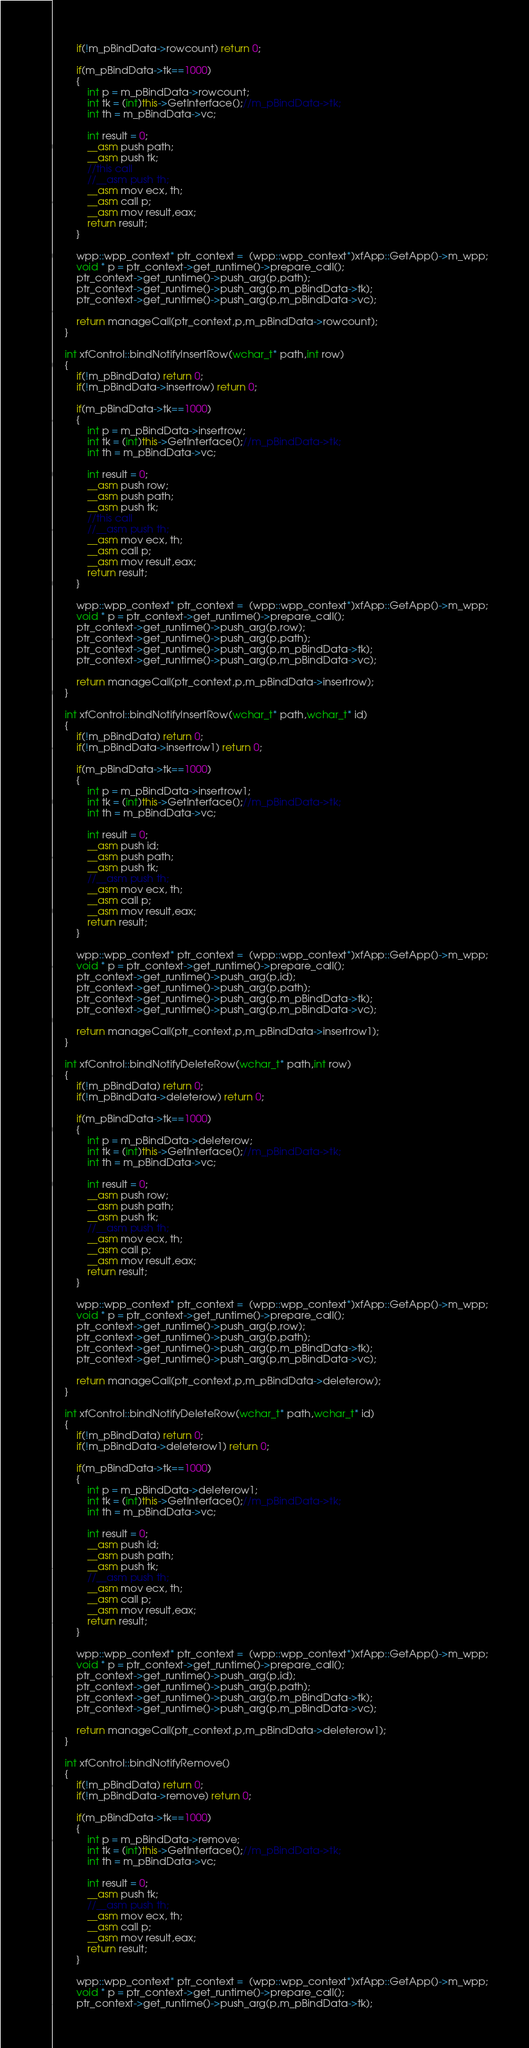Convert code to text. <code><loc_0><loc_0><loc_500><loc_500><_C++_>		if(!m_pBindData->rowcount) return 0;

		if(m_pBindData->tk==1000)
		{
			int p = m_pBindData->rowcount;
			int tk = (int)this->GetInterface();//m_pBindData->tk;
			int th = m_pBindData->vc;

			int result = 0;
			__asm push path;
			__asm push tk;
			//this call
			//__asm push th;
			__asm mov ecx, th;
			__asm call p;
			__asm mov result,eax;
			return result;
		}

		wpp::wpp_context* ptr_context =  (wpp::wpp_context*)xfApp::GetApp()->m_wpp;
		void * p = ptr_context->get_runtime()->prepare_call();
		ptr_context->get_runtime()->push_arg(p,path);
		ptr_context->get_runtime()->push_arg(p,m_pBindData->tk);
		ptr_context->get_runtime()->push_arg(p,m_pBindData->vc);
		
		return manageCall(ptr_context,p,m_pBindData->rowcount);
	}

	int xfControl::bindNotifyInsertRow(wchar_t* path,int row)
	{
		if(!m_pBindData) return 0;
		if(!m_pBindData->insertrow) return 0;

		if(m_pBindData->tk==1000)
		{
			int p = m_pBindData->insertrow;
			int tk = (int)this->GetInterface();//m_pBindData->tk;
			int th = m_pBindData->vc;

			int result = 0;
			__asm push row;
			__asm push path;
			__asm push tk;
			//this call
			//__asm push th;
			__asm mov ecx, th;
			__asm call p;
			__asm mov result,eax;
			return result;
		}

		wpp::wpp_context* ptr_context =  (wpp::wpp_context*)xfApp::GetApp()->m_wpp;
		void * p = ptr_context->get_runtime()->prepare_call();
		ptr_context->get_runtime()->push_arg(p,row);
		ptr_context->get_runtime()->push_arg(p,path);
		ptr_context->get_runtime()->push_arg(p,m_pBindData->tk);
		ptr_context->get_runtime()->push_arg(p,m_pBindData->vc);
		
		return manageCall(ptr_context,p,m_pBindData->insertrow);
	}

	int xfControl::bindNotifyInsertRow(wchar_t* path,wchar_t* id)
	{
		if(!m_pBindData) return 0;
		if(!m_pBindData->insertrow1) return 0;

		if(m_pBindData->tk==1000)
		{
			int p = m_pBindData->insertrow1;
			int tk = (int)this->GetInterface();//m_pBindData->tk;
			int th = m_pBindData->vc;

			int result = 0;
			__asm push id;
			__asm push path;
			__asm push tk;
			//__asm push th;
			__asm mov ecx, th;
			__asm call p;
			__asm mov result,eax;
			return result;
		}

		wpp::wpp_context* ptr_context =  (wpp::wpp_context*)xfApp::GetApp()->m_wpp;
		void * p = ptr_context->get_runtime()->prepare_call();
		ptr_context->get_runtime()->push_arg(p,id);
		ptr_context->get_runtime()->push_arg(p,path);
		ptr_context->get_runtime()->push_arg(p,m_pBindData->tk);
		ptr_context->get_runtime()->push_arg(p,m_pBindData->vc);
		
		return manageCall(ptr_context,p,m_pBindData->insertrow1);
	}

	int xfControl::bindNotifyDeleteRow(wchar_t* path,int row)
	{
		if(!m_pBindData) return 0;
		if(!m_pBindData->deleterow) return 0;

		if(m_pBindData->tk==1000)
		{
			int p = m_pBindData->deleterow;
			int tk = (int)this->GetInterface();//m_pBindData->tk;
			int th = m_pBindData->vc;

			int result = 0;
			__asm push row;
			__asm push path;
			__asm push tk;
			//__asm push th;
			__asm mov ecx, th;
			__asm call p;
			__asm mov result,eax; 
			return result;
		}

		wpp::wpp_context* ptr_context =  (wpp::wpp_context*)xfApp::GetApp()->m_wpp;
		void * p = ptr_context->get_runtime()->prepare_call();
		ptr_context->get_runtime()->push_arg(p,row);
		ptr_context->get_runtime()->push_arg(p,path);
		ptr_context->get_runtime()->push_arg(p,m_pBindData->tk);
		ptr_context->get_runtime()->push_arg(p,m_pBindData->vc);
		
		return manageCall(ptr_context,p,m_pBindData->deleterow);
	}

	int xfControl::bindNotifyDeleteRow(wchar_t* path,wchar_t* id)
	{
		if(!m_pBindData) return 0;
		if(!m_pBindData->deleterow1) return 0;

		if(m_pBindData->tk==1000)
		{
			int p = m_pBindData->deleterow1;
			int tk = (int)this->GetInterface();//m_pBindData->tk;
			int th = m_pBindData->vc;

			int result = 0;
			__asm push id;
			__asm push path;
			__asm push tk;
			//__asm push th;
			__asm mov ecx, th;
			__asm call p;
			__asm mov result,eax; 
			return result;
		}

		wpp::wpp_context* ptr_context =  (wpp::wpp_context*)xfApp::GetApp()->m_wpp;
		void * p = ptr_context->get_runtime()->prepare_call();
		ptr_context->get_runtime()->push_arg(p,id);
		ptr_context->get_runtime()->push_arg(p,path);
		ptr_context->get_runtime()->push_arg(p,m_pBindData->tk);
		ptr_context->get_runtime()->push_arg(p,m_pBindData->vc);
		
		return manageCall(ptr_context,p,m_pBindData->deleterow1);
	}

	int xfControl::bindNotifyRemove()
	{
		if(!m_pBindData) return 0;
		if(!m_pBindData->remove) return 0;

		if(m_pBindData->tk==1000)
		{
			int p = m_pBindData->remove;
			int tk = (int)this->GetInterface();//m_pBindData->tk;
			int th = m_pBindData->vc;

			int result = 0;
			__asm push tk;
			//__asm push th;
			__asm mov ecx, th;
			__asm call p;
			__asm mov result,eax;
			return result; 
		}

		wpp::wpp_context* ptr_context =  (wpp::wpp_context*)xfApp::GetApp()->m_wpp;
		void * p = ptr_context->get_runtime()->prepare_call();
		ptr_context->get_runtime()->push_arg(p,m_pBindData->tk);</code> 